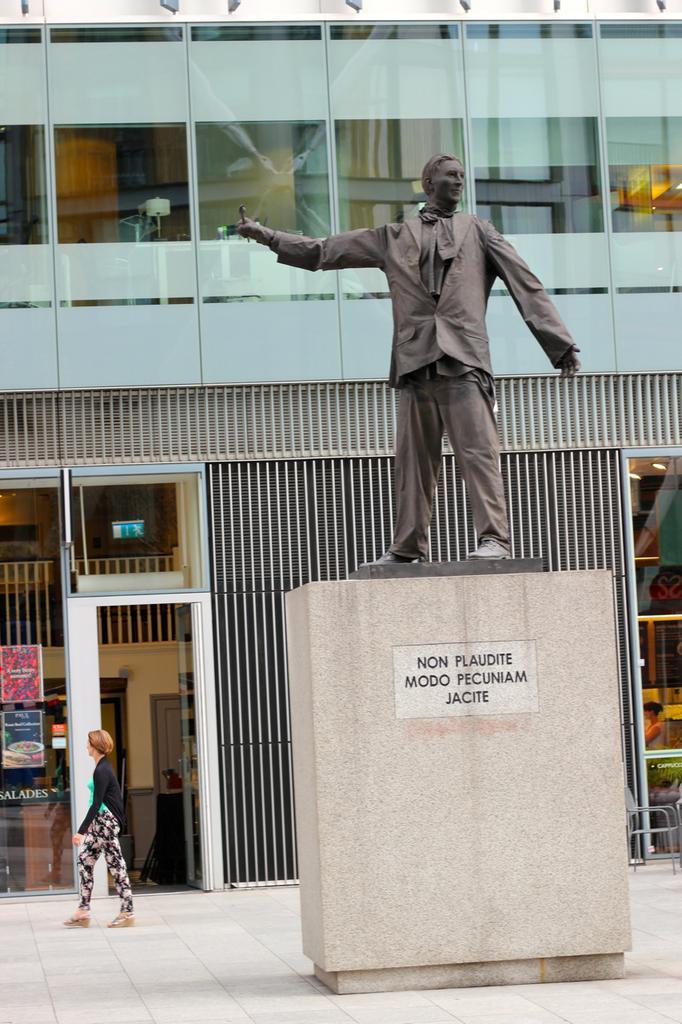Could you give a brief overview of what you see in this image? This picture is clicked outside the city. In the middle of the picture, we see the statue of the man placed on the pillar. Beside that, the woman in black jacket is walking. Behind her, we see a building which is in white color and we even see some posters pasted on that building. 